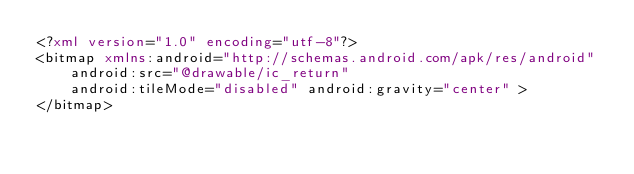Convert code to text. <code><loc_0><loc_0><loc_500><loc_500><_XML_><?xml version="1.0" encoding="utf-8"?>
<bitmap xmlns:android="http://schemas.android.com/apk/res/android"
    android:src="@drawable/ic_return"
    android:tileMode="disabled" android:gravity="center" >
</bitmap></code> 